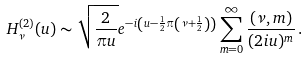<formula> <loc_0><loc_0><loc_500><loc_500>H _ { \nu } ^ { ( 2 ) } ( u ) \sim \sqrt { \frac { 2 } { \pi u } } e ^ { - i \left ( u - \frac { 1 } { 2 } \pi \left ( \nu + \frac { 1 } { 2 } \right ) \right ) } \sum _ { m = 0 } ^ { \infty } \frac { ( \nu , m ) } { ( 2 i u ) ^ { m } } \, .</formula> 